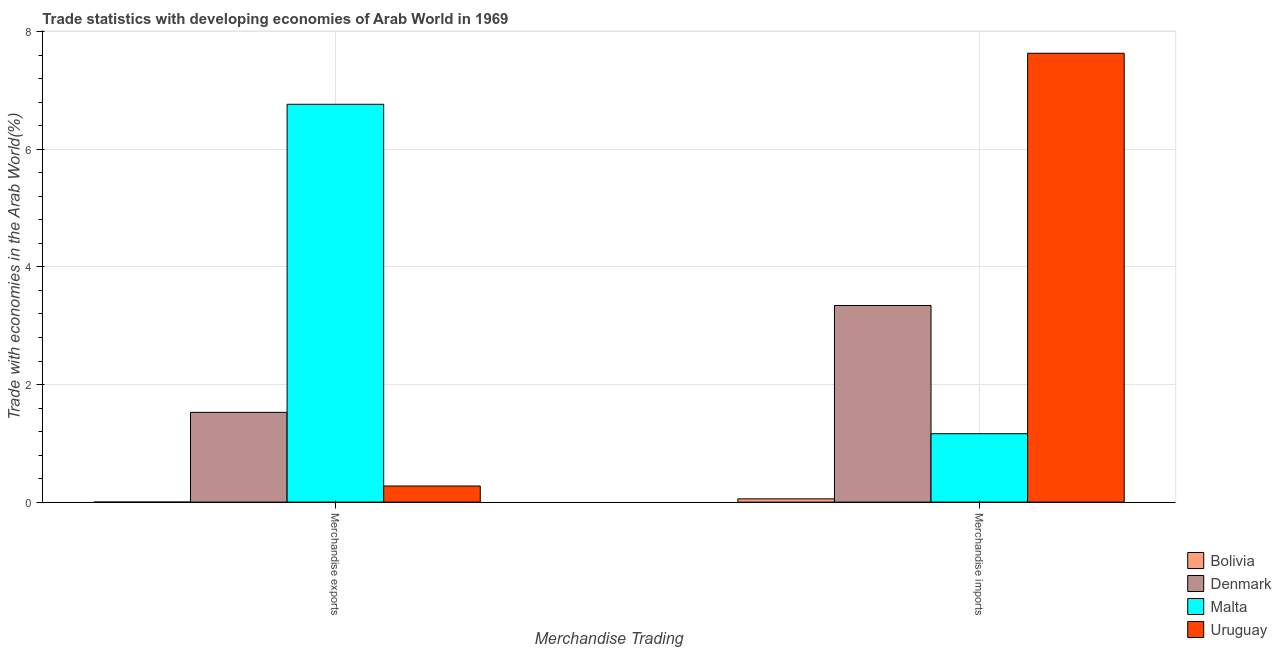How many different coloured bars are there?
Offer a terse response. 4. How many groups of bars are there?
Offer a terse response. 2. Are the number of bars per tick equal to the number of legend labels?
Offer a very short reply. Yes. How many bars are there on the 2nd tick from the right?
Give a very brief answer. 4. What is the merchandise imports in Uruguay?
Your answer should be very brief. 7.63. Across all countries, what is the maximum merchandise imports?
Offer a terse response. 7.63. Across all countries, what is the minimum merchandise imports?
Your answer should be very brief. 0.06. In which country was the merchandise imports maximum?
Your answer should be very brief. Uruguay. In which country was the merchandise imports minimum?
Provide a short and direct response. Bolivia. What is the total merchandise exports in the graph?
Provide a short and direct response. 8.57. What is the difference between the merchandise exports in Bolivia and that in Uruguay?
Give a very brief answer. -0.27. What is the difference between the merchandise imports in Bolivia and the merchandise exports in Uruguay?
Your answer should be compact. -0.22. What is the average merchandise imports per country?
Keep it short and to the point. 3.05. What is the difference between the merchandise exports and merchandise imports in Denmark?
Offer a very short reply. -1.82. In how many countries, is the merchandise imports greater than 5.6 %?
Give a very brief answer. 1. What is the ratio of the merchandise imports in Bolivia to that in Denmark?
Offer a very short reply. 0.02. What does the 3rd bar from the left in Merchandise imports represents?
Make the answer very short. Malta. What does the 2nd bar from the right in Merchandise exports represents?
Your response must be concise. Malta. How many bars are there?
Provide a short and direct response. 8. Are all the bars in the graph horizontal?
Make the answer very short. No. Where does the legend appear in the graph?
Your answer should be compact. Bottom right. How many legend labels are there?
Keep it short and to the point. 4. How are the legend labels stacked?
Provide a succinct answer. Vertical. What is the title of the graph?
Your answer should be compact. Trade statistics with developing economies of Arab World in 1969. Does "Thailand" appear as one of the legend labels in the graph?
Provide a succinct answer. No. What is the label or title of the X-axis?
Provide a short and direct response. Merchandise Trading. What is the label or title of the Y-axis?
Give a very brief answer. Trade with economies in the Arab World(%). What is the Trade with economies in the Arab World(%) in Bolivia in Merchandise exports?
Make the answer very short. 0. What is the Trade with economies in the Arab World(%) in Denmark in Merchandise exports?
Ensure brevity in your answer.  1.53. What is the Trade with economies in the Arab World(%) in Malta in Merchandise exports?
Make the answer very short. 6.77. What is the Trade with economies in the Arab World(%) in Uruguay in Merchandise exports?
Give a very brief answer. 0.27. What is the Trade with economies in the Arab World(%) of Bolivia in Merchandise imports?
Offer a very short reply. 0.06. What is the Trade with economies in the Arab World(%) of Denmark in Merchandise imports?
Your response must be concise. 3.34. What is the Trade with economies in the Arab World(%) of Malta in Merchandise imports?
Your response must be concise. 1.16. What is the Trade with economies in the Arab World(%) of Uruguay in Merchandise imports?
Your answer should be compact. 7.63. Across all Merchandise Trading, what is the maximum Trade with economies in the Arab World(%) in Bolivia?
Your answer should be compact. 0.06. Across all Merchandise Trading, what is the maximum Trade with economies in the Arab World(%) of Denmark?
Provide a short and direct response. 3.34. Across all Merchandise Trading, what is the maximum Trade with economies in the Arab World(%) in Malta?
Give a very brief answer. 6.77. Across all Merchandise Trading, what is the maximum Trade with economies in the Arab World(%) of Uruguay?
Make the answer very short. 7.63. Across all Merchandise Trading, what is the minimum Trade with economies in the Arab World(%) in Bolivia?
Your response must be concise. 0. Across all Merchandise Trading, what is the minimum Trade with economies in the Arab World(%) in Denmark?
Your answer should be compact. 1.53. Across all Merchandise Trading, what is the minimum Trade with economies in the Arab World(%) of Malta?
Your answer should be compact. 1.16. Across all Merchandise Trading, what is the minimum Trade with economies in the Arab World(%) of Uruguay?
Provide a short and direct response. 0.27. What is the total Trade with economies in the Arab World(%) of Bolivia in the graph?
Your response must be concise. 0.06. What is the total Trade with economies in the Arab World(%) in Denmark in the graph?
Provide a short and direct response. 4.87. What is the total Trade with economies in the Arab World(%) in Malta in the graph?
Your answer should be compact. 7.93. What is the total Trade with economies in the Arab World(%) in Uruguay in the graph?
Provide a short and direct response. 7.91. What is the difference between the Trade with economies in the Arab World(%) of Bolivia in Merchandise exports and that in Merchandise imports?
Offer a terse response. -0.06. What is the difference between the Trade with economies in the Arab World(%) in Denmark in Merchandise exports and that in Merchandise imports?
Your response must be concise. -1.82. What is the difference between the Trade with economies in the Arab World(%) in Malta in Merchandise exports and that in Merchandise imports?
Offer a terse response. 5.6. What is the difference between the Trade with economies in the Arab World(%) of Uruguay in Merchandise exports and that in Merchandise imports?
Provide a succinct answer. -7.36. What is the difference between the Trade with economies in the Arab World(%) of Bolivia in Merchandise exports and the Trade with economies in the Arab World(%) of Denmark in Merchandise imports?
Your answer should be very brief. -3.34. What is the difference between the Trade with economies in the Arab World(%) in Bolivia in Merchandise exports and the Trade with economies in the Arab World(%) in Malta in Merchandise imports?
Your answer should be very brief. -1.16. What is the difference between the Trade with economies in the Arab World(%) in Bolivia in Merchandise exports and the Trade with economies in the Arab World(%) in Uruguay in Merchandise imports?
Make the answer very short. -7.63. What is the difference between the Trade with economies in the Arab World(%) in Denmark in Merchandise exports and the Trade with economies in the Arab World(%) in Malta in Merchandise imports?
Provide a succinct answer. 0.36. What is the difference between the Trade with economies in the Arab World(%) in Denmark in Merchandise exports and the Trade with economies in the Arab World(%) in Uruguay in Merchandise imports?
Offer a very short reply. -6.11. What is the difference between the Trade with economies in the Arab World(%) in Malta in Merchandise exports and the Trade with economies in the Arab World(%) in Uruguay in Merchandise imports?
Offer a terse response. -0.87. What is the average Trade with economies in the Arab World(%) of Bolivia per Merchandise Trading?
Keep it short and to the point. 0.03. What is the average Trade with economies in the Arab World(%) in Denmark per Merchandise Trading?
Your answer should be compact. 2.44. What is the average Trade with economies in the Arab World(%) in Malta per Merchandise Trading?
Offer a terse response. 3.96. What is the average Trade with economies in the Arab World(%) of Uruguay per Merchandise Trading?
Make the answer very short. 3.95. What is the difference between the Trade with economies in the Arab World(%) in Bolivia and Trade with economies in the Arab World(%) in Denmark in Merchandise exports?
Your response must be concise. -1.53. What is the difference between the Trade with economies in the Arab World(%) in Bolivia and Trade with economies in the Arab World(%) in Malta in Merchandise exports?
Make the answer very short. -6.77. What is the difference between the Trade with economies in the Arab World(%) in Bolivia and Trade with economies in the Arab World(%) in Uruguay in Merchandise exports?
Your response must be concise. -0.27. What is the difference between the Trade with economies in the Arab World(%) in Denmark and Trade with economies in the Arab World(%) in Malta in Merchandise exports?
Provide a succinct answer. -5.24. What is the difference between the Trade with economies in the Arab World(%) in Denmark and Trade with economies in the Arab World(%) in Uruguay in Merchandise exports?
Offer a very short reply. 1.25. What is the difference between the Trade with economies in the Arab World(%) of Malta and Trade with economies in the Arab World(%) of Uruguay in Merchandise exports?
Give a very brief answer. 6.49. What is the difference between the Trade with economies in the Arab World(%) in Bolivia and Trade with economies in the Arab World(%) in Denmark in Merchandise imports?
Offer a terse response. -3.29. What is the difference between the Trade with economies in the Arab World(%) in Bolivia and Trade with economies in the Arab World(%) in Malta in Merchandise imports?
Provide a short and direct response. -1.11. What is the difference between the Trade with economies in the Arab World(%) in Bolivia and Trade with economies in the Arab World(%) in Uruguay in Merchandise imports?
Provide a short and direct response. -7.58. What is the difference between the Trade with economies in the Arab World(%) in Denmark and Trade with economies in the Arab World(%) in Malta in Merchandise imports?
Offer a terse response. 2.18. What is the difference between the Trade with economies in the Arab World(%) of Denmark and Trade with economies in the Arab World(%) of Uruguay in Merchandise imports?
Your response must be concise. -4.29. What is the difference between the Trade with economies in the Arab World(%) of Malta and Trade with economies in the Arab World(%) of Uruguay in Merchandise imports?
Give a very brief answer. -6.47. What is the ratio of the Trade with economies in the Arab World(%) in Bolivia in Merchandise exports to that in Merchandise imports?
Your answer should be very brief. 0.01. What is the ratio of the Trade with economies in the Arab World(%) in Denmark in Merchandise exports to that in Merchandise imports?
Your answer should be very brief. 0.46. What is the ratio of the Trade with economies in the Arab World(%) in Malta in Merchandise exports to that in Merchandise imports?
Give a very brief answer. 5.81. What is the ratio of the Trade with economies in the Arab World(%) of Uruguay in Merchandise exports to that in Merchandise imports?
Provide a succinct answer. 0.04. What is the difference between the highest and the second highest Trade with economies in the Arab World(%) of Bolivia?
Offer a very short reply. 0.06. What is the difference between the highest and the second highest Trade with economies in the Arab World(%) of Denmark?
Offer a very short reply. 1.82. What is the difference between the highest and the second highest Trade with economies in the Arab World(%) of Malta?
Offer a very short reply. 5.6. What is the difference between the highest and the second highest Trade with economies in the Arab World(%) of Uruguay?
Provide a short and direct response. 7.36. What is the difference between the highest and the lowest Trade with economies in the Arab World(%) in Bolivia?
Offer a very short reply. 0.06. What is the difference between the highest and the lowest Trade with economies in the Arab World(%) in Denmark?
Offer a very short reply. 1.82. What is the difference between the highest and the lowest Trade with economies in the Arab World(%) in Malta?
Offer a very short reply. 5.6. What is the difference between the highest and the lowest Trade with economies in the Arab World(%) of Uruguay?
Ensure brevity in your answer.  7.36. 